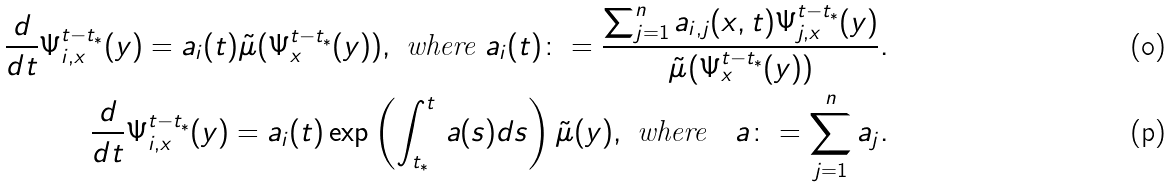<formula> <loc_0><loc_0><loc_500><loc_500>\frac { d } { d t } \Psi _ { i , x } ^ { t - t _ { * } } ( y ) = a _ { i } ( t ) \tilde { \mu } ( \Psi _ { x } ^ { t - t _ { * } } ( y ) ) , \ \text {where} \ a _ { i } ( t ) \colon = \frac { \sum _ { j = 1 } ^ { n } a _ { i , j } ( x , t ) \Psi _ { j , x } ^ { t - t _ { * } } ( y ) } { \tilde { \mu } ( \Psi _ { x } ^ { t - t _ { * } } ( y ) ) } . \\ \frac { d } { d t } \Psi _ { i , x } ^ { t - t _ { * } } ( y ) = a _ { i } ( t ) \exp \left ( \int _ { t _ { * } } ^ { t } \, a ( s ) d s \right ) \tilde { \mu } ( y ) , \ \text {where} \quad a \colon = \sum _ { j = 1 } ^ { n } a _ { j } .</formula> 